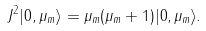<formula> <loc_0><loc_0><loc_500><loc_500>J ^ { 2 } | 0 , \mu _ { m } \rangle = \mu _ { m } ( \mu _ { m } + 1 ) | 0 , \mu _ { m } \rangle .</formula> 